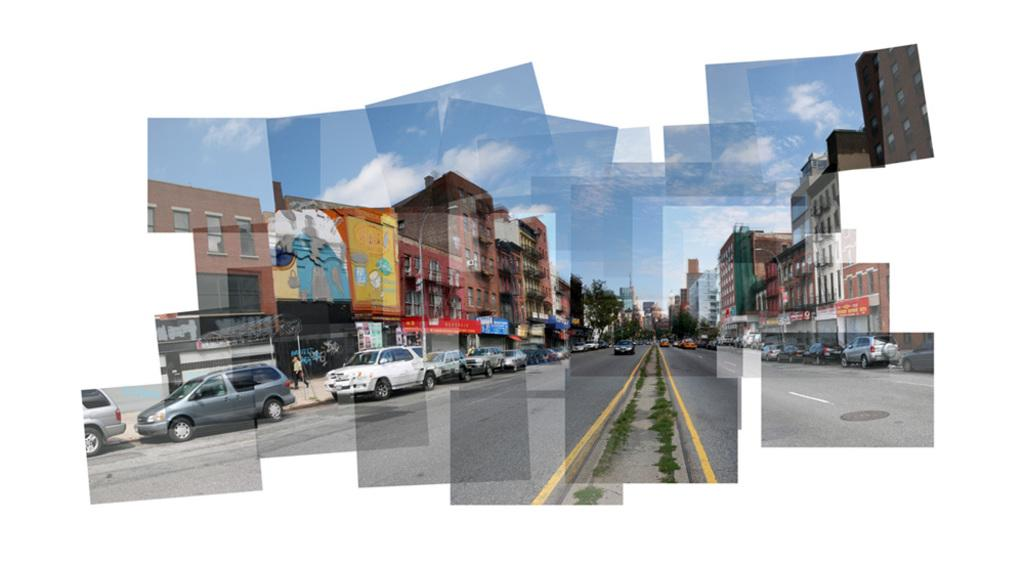What can be seen on the road in the image? There are vehicles on the road in the image. What is visible in the background of the image? There are buildings, people, and the sky visible in the background of the image. What type of signs or notices are present in the image? There are boards with writing on them in the image. What type of cream can be seen being measured by the cannon in the image? There is no cream or cannon present in the image. 